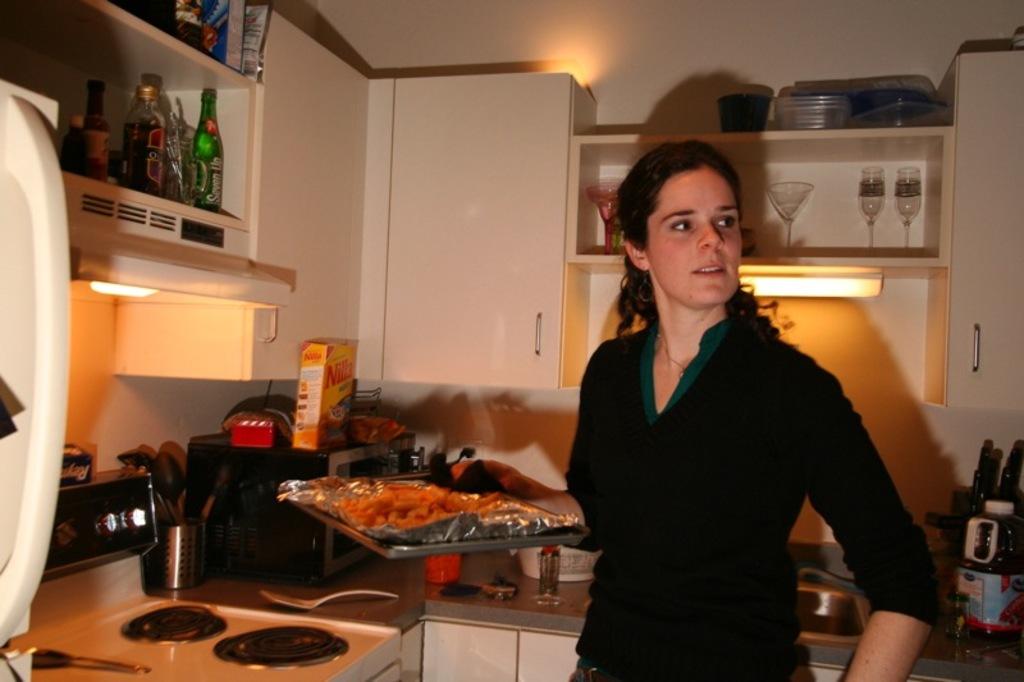What kind of cookies can be seen?
Provide a succinct answer. Nilla. What kind of juice is on the bottom right?
Ensure brevity in your answer.  Cranberry. 